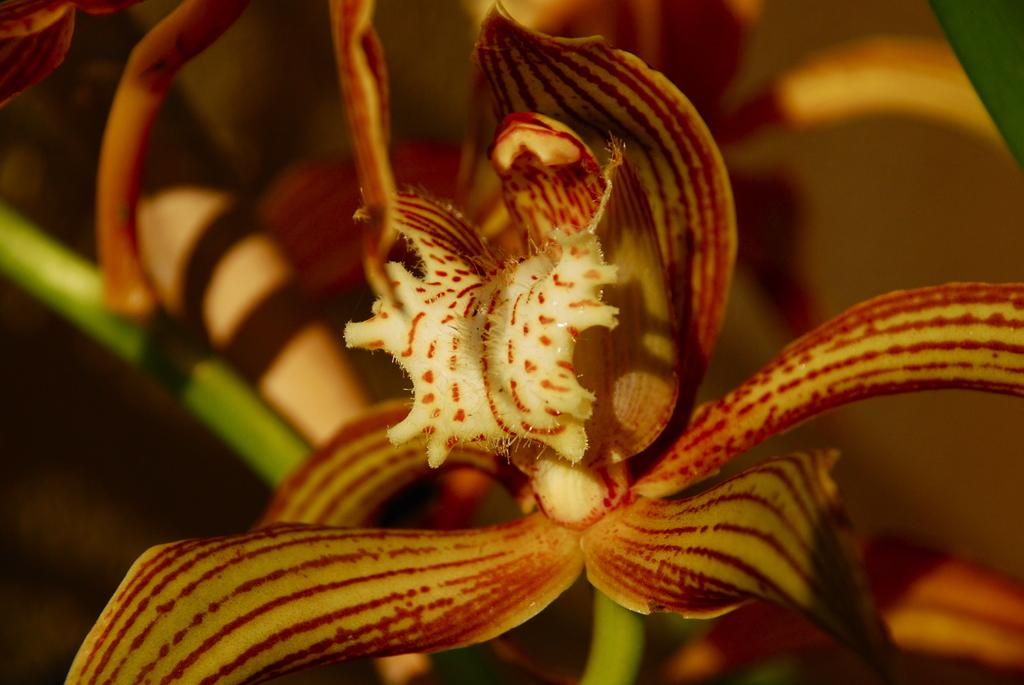What type of flower is in the image? There is a slipper orchids flower in the image. What else can be seen in the image besides the flower? There is a plant in the image. Can you tell me how many bees are buzzing around the flower in the image? There are no bees present in the image; it only shows the flower and the plant. What is the answer to the question about the fall season in the image? There is no mention of the fall season or any related questions in the image. 